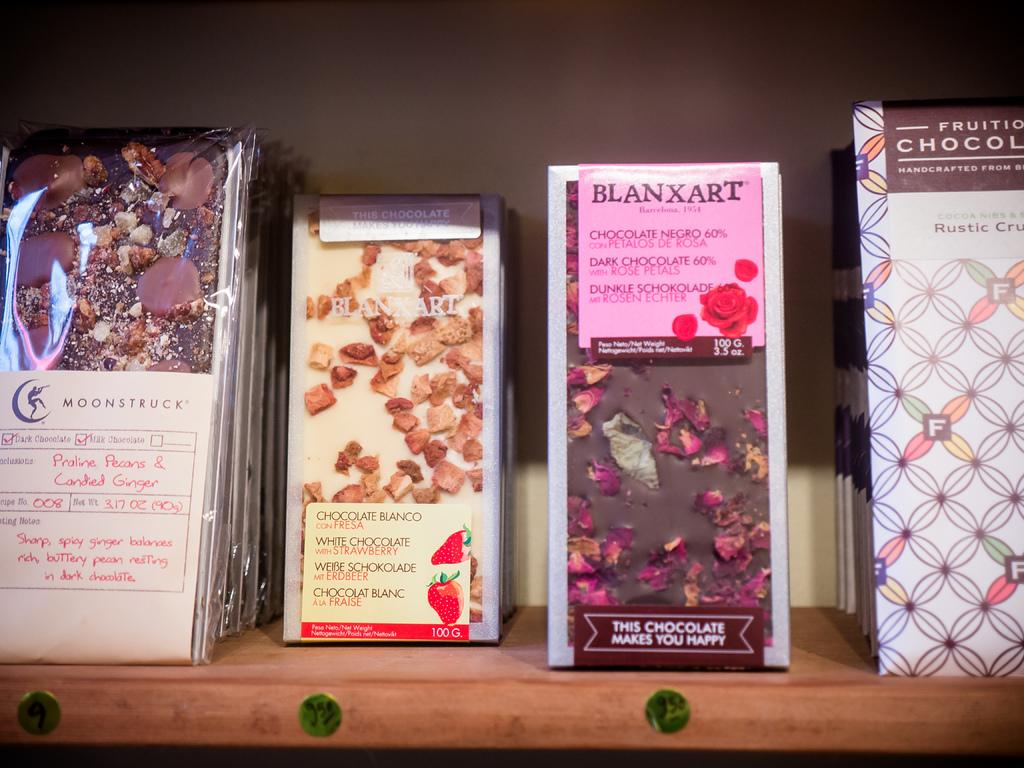What type of items are visible in the image? The image contains various chocolates in wrappers. Where are the chocolates placed? The chocolates are placed on a wooden shelf. What can be seen in the background of the image? The background of the image is a well. What type of flower is growing in the can in the image? There is no can or flower present in the image; it features chocolates on a wooden shelf with a well in the background. 